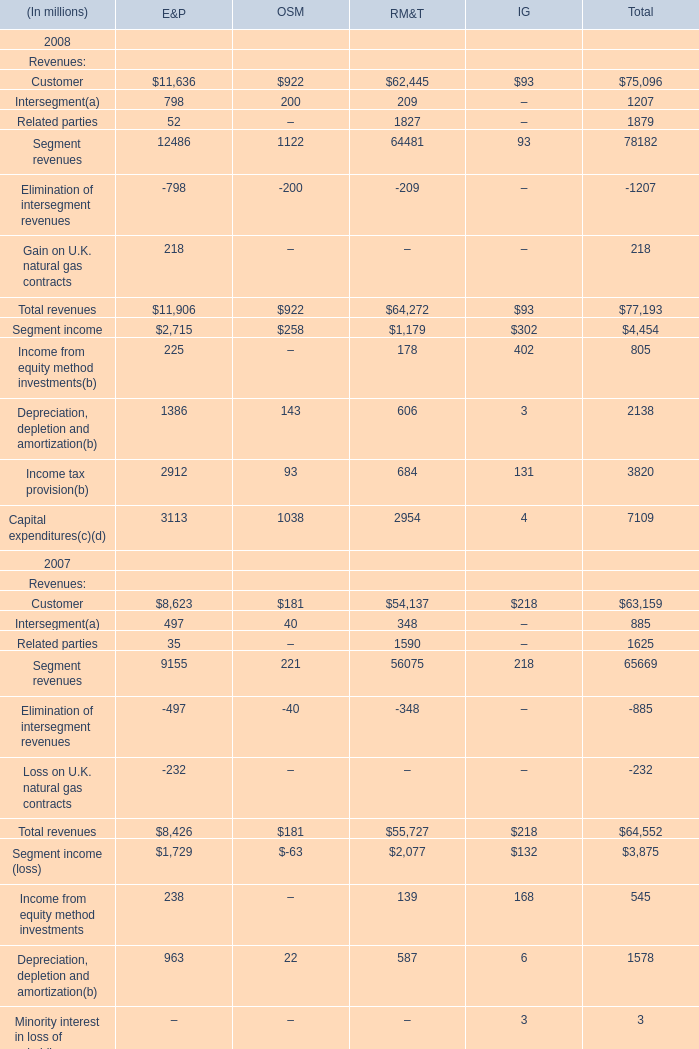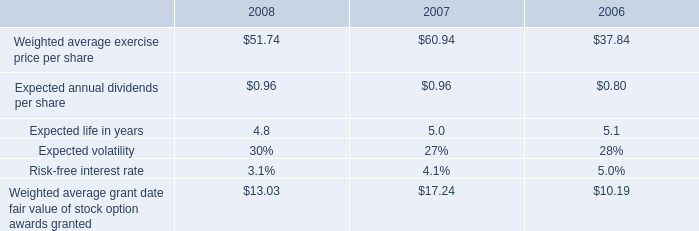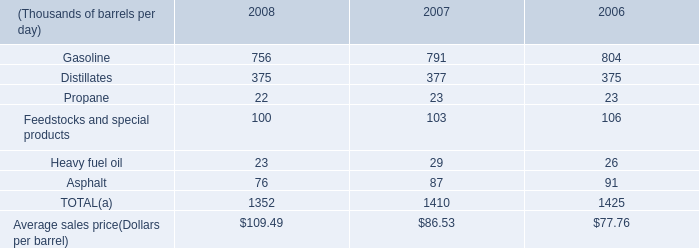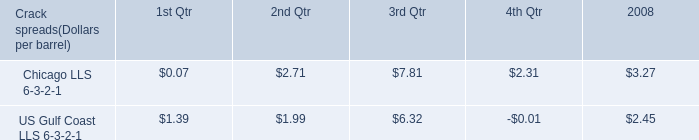In the year with largest amount of Customer, what's the increasing rate of Total revenues? 
Computations: ((77193 - 64552) / 77193)
Answer: 0.16376. 